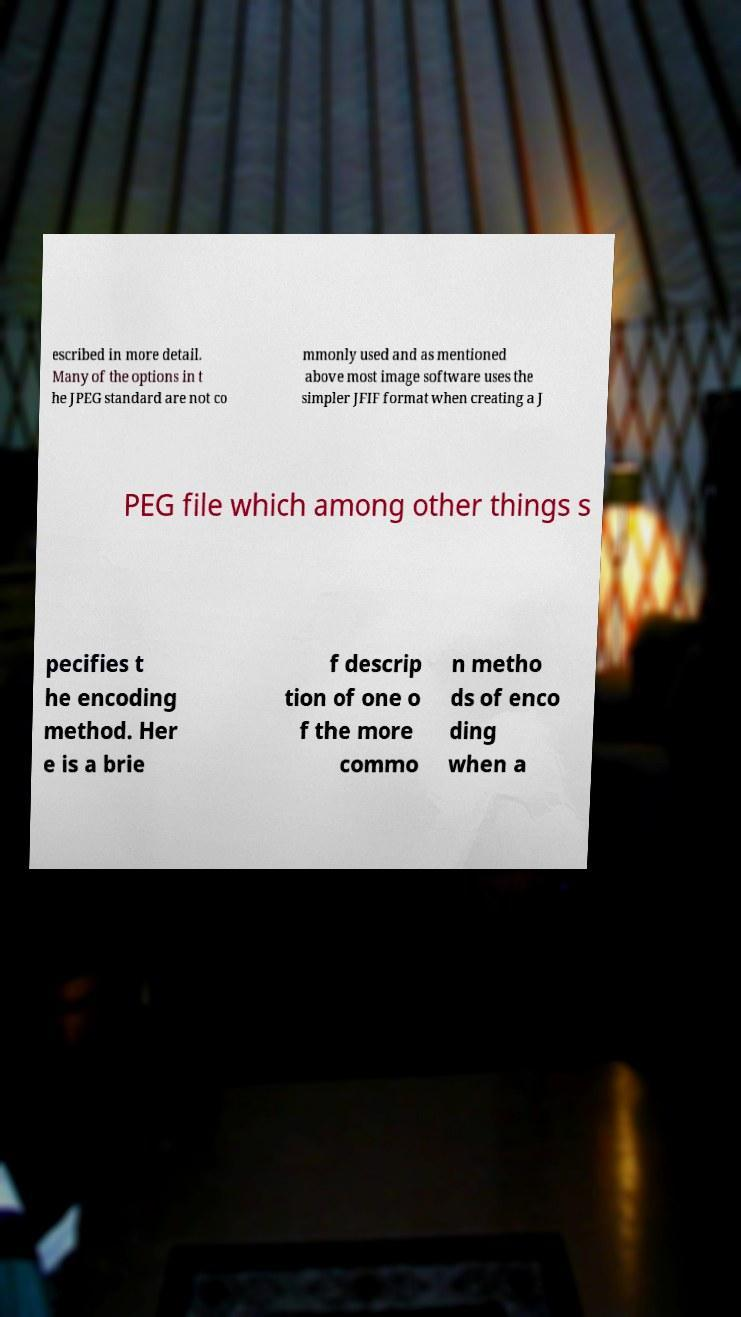Please read and relay the text visible in this image. What does it say? escribed in more detail. Many of the options in t he JPEG standard are not co mmonly used and as mentioned above most image software uses the simpler JFIF format when creating a J PEG file which among other things s pecifies t he encoding method. Her e is a brie f descrip tion of one o f the more commo n metho ds of enco ding when a 